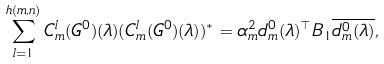Convert formula to latex. <formula><loc_0><loc_0><loc_500><loc_500>\sum _ { l = 1 } ^ { h ( m , n ) } C _ { m } ^ { l } ( G ^ { 0 } ) ( \lambda ) ( C _ { m } ^ { l } ( G ^ { 0 } ) ( \lambda ) ) ^ { * } = \alpha _ { m } ^ { 2 } d _ { m } ^ { 0 } ( \lambda ) ^ { \top } B _ { 1 } \overline { d _ { m } ^ { 0 } ( \lambda ) } ,</formula> 